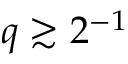<formula> <loc_0><loc_0><loc_500><loc_500>q \gtrsim 2 \AA ^ { - 1 }</formula> 